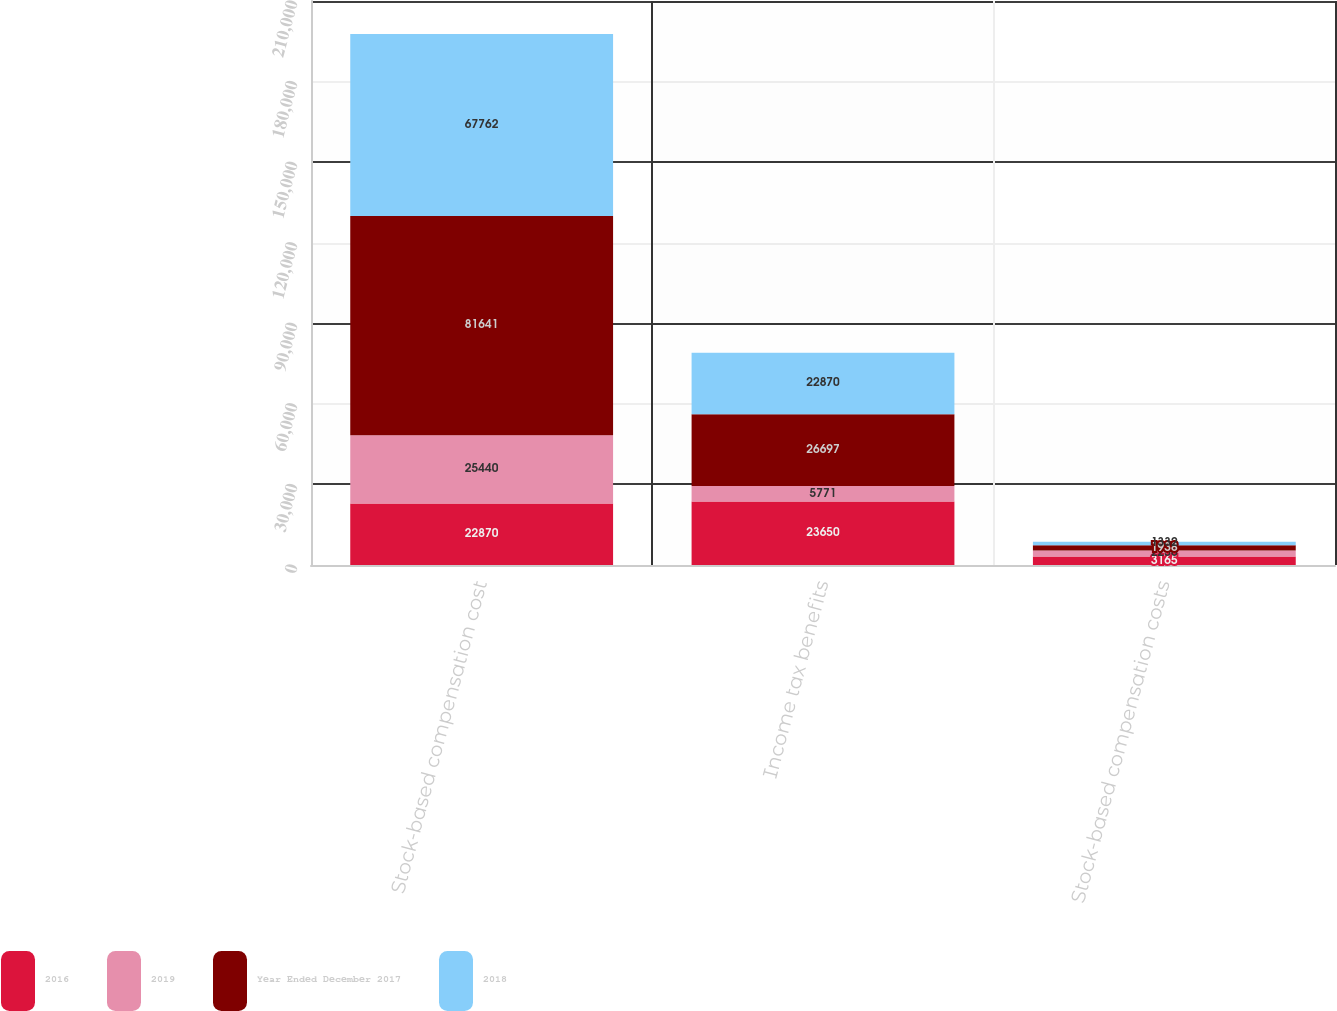<chart> <loc_0><loc_0><loc_500><loc_500><stacked_bar_chart><ecel><fcel>Stock-based compensation cost<fcel>Income tax benefits<fcel>Stock-based compensation costs<nl><fcel>2016<fcel>22870<fcel>23650<fcel>3165<nl><fcel>2019<fcel>25440<fcel>5771<fcel>2236<nl><fcel>Year Ended December 2017<fcel>81641<fcel>26697<fcel>1938<nl><fcel>2018<fcel>67762<fcel>22870<fcel>1332<nl></chart> 